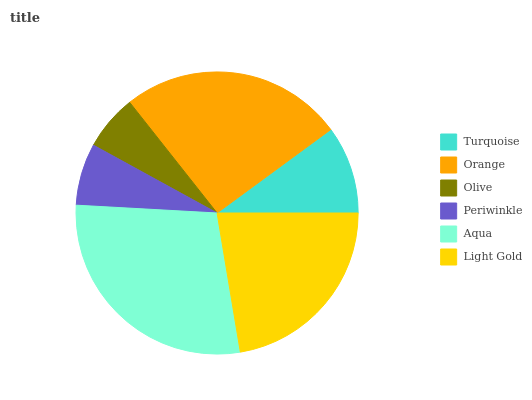Is Olive the minimum?
Answer yes or no. Yes. Is Aqua the maximum?
Answer yes or no. Yes. Is Orange the minimum?
Answer yes or no. No. Is Orange the maximum?
Answer yes or no. No. Is Orange greater than Turquoise?
Answer yes or no. Yes. Is Turquoise less than Orange?
Answer yes or no. Yes. Is Turquoise greater than Orange?
Answer yes or no. No. Is Orange less than Turquoise?
Answer yes or no. No. Is Light Gold the high median?
Answer yes or no. Yes. Is Turquoise the low median?
Answer yes or no. Yes. Is Orange the high median?
Answer yes or no. No. Is Olive the low median?
Answer yes or no. No. 